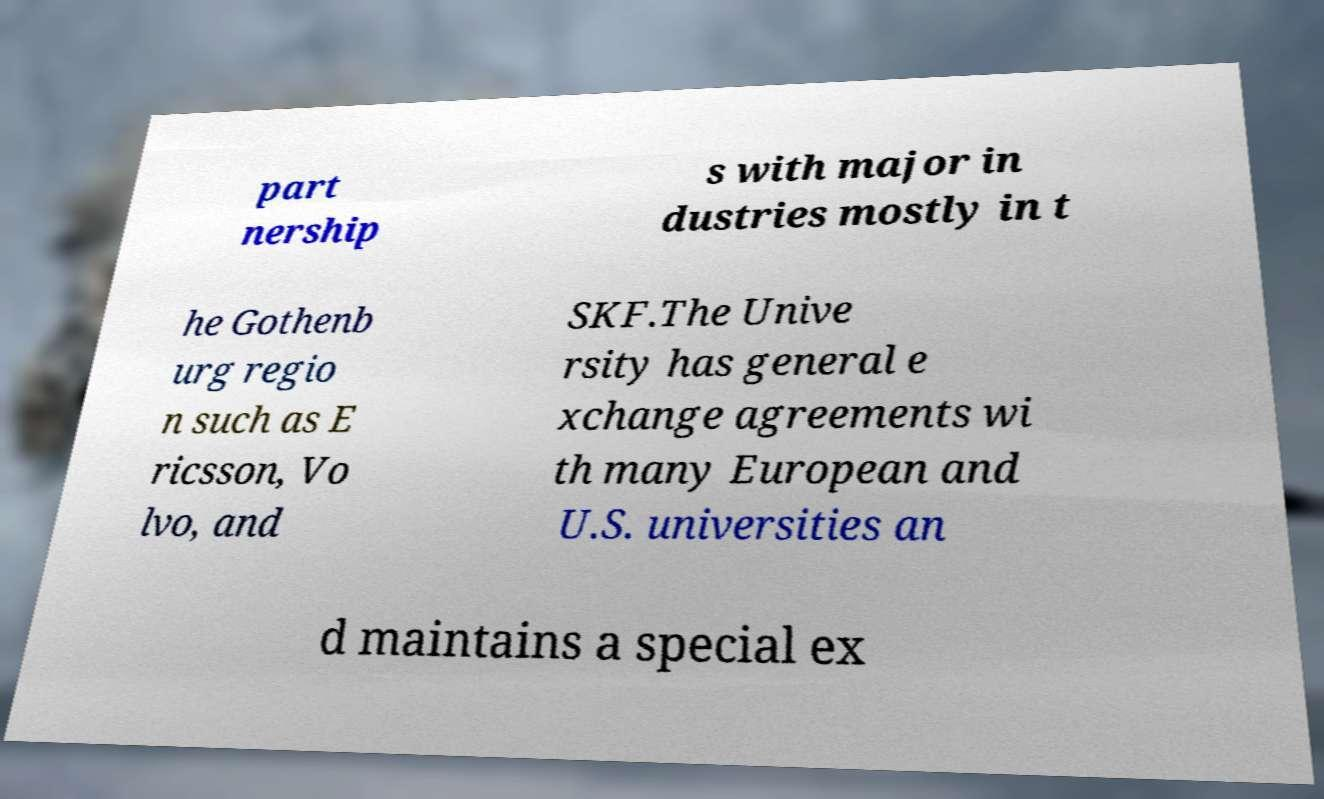Can you read and provide the text displayed in the image?This photo seems to have some interesting text. Can you extract and type it out for me? part nership s with major in dustries mostly in t he Gothenb urg regio n such as E ricsson, Vo lvo, and SKF.The Unive rsity has general e xchange agreements wi th many European and U.S. universities an d maintains a special ex 